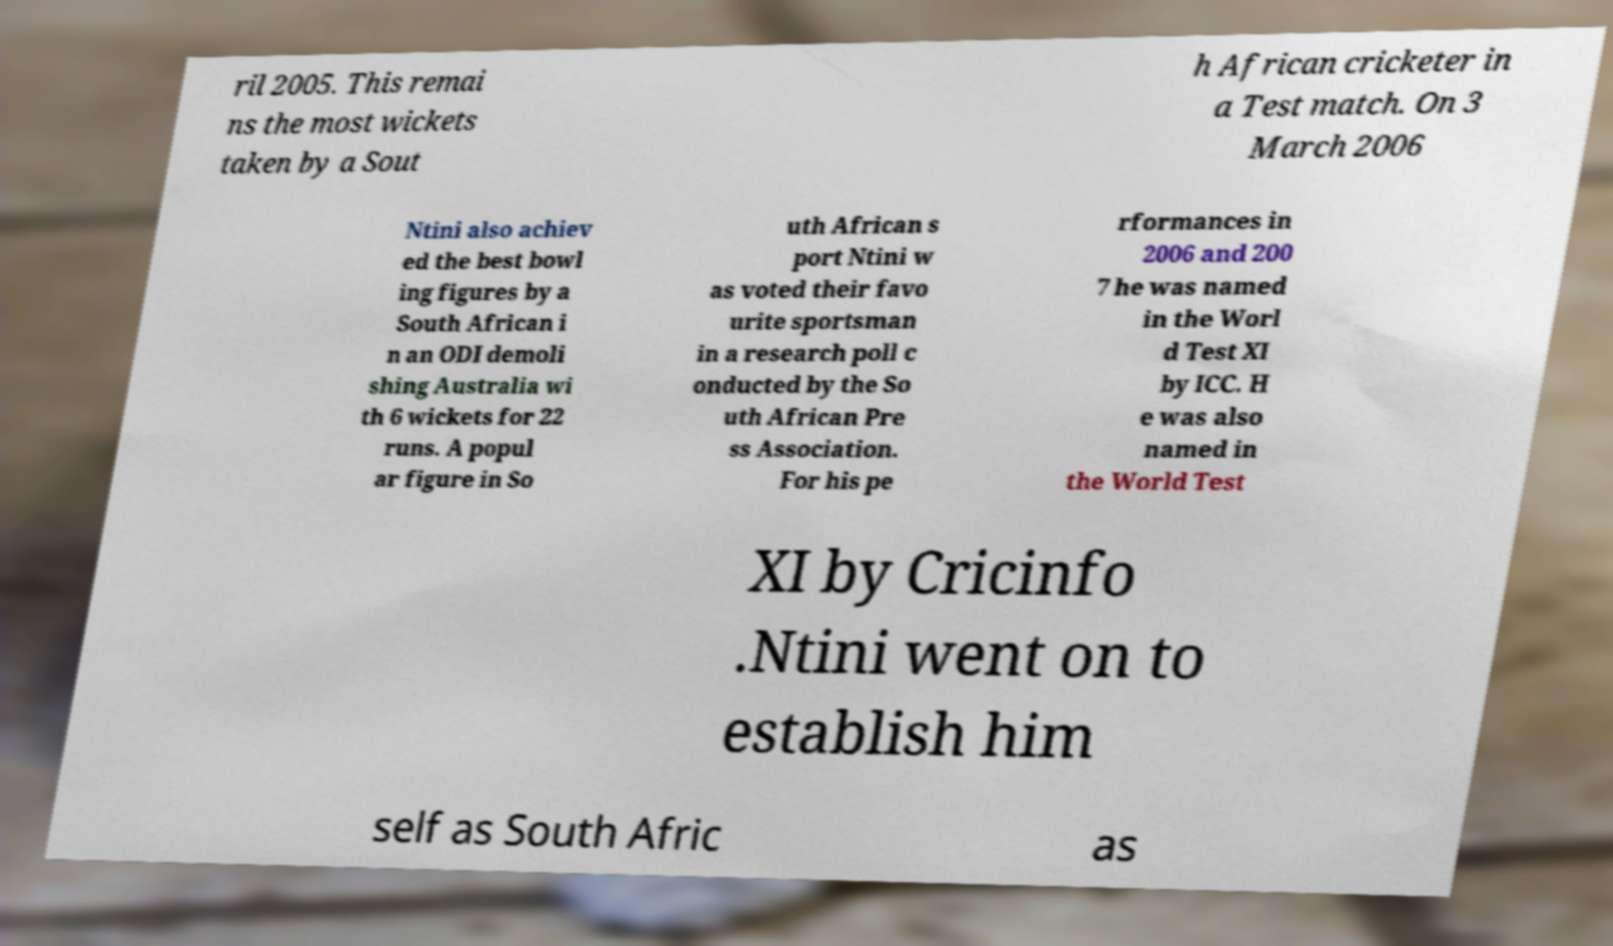Could you extract and type out the text from this image? ril 2005. This remai ns the most wickets taken by a Sout h African cricketer in a Test match. On 3 March 2006 Ntini also achiev ed the best bowl ing figures by a South African i n an ODI demoli shing Australia wi th 6 wickets for 22 runs. A popul ar figure in So uth African s port Ntini w as voted their favo urite sportsman in a research poll c onducted by the So uth African Pre ss Association. For his pe rformances in 2006 and 200 7 he was named in the Worl d Test XI by ICC. H e was also named in the World Test XI by Cricinfo .Ntini went on to establish him self as South Afric as 